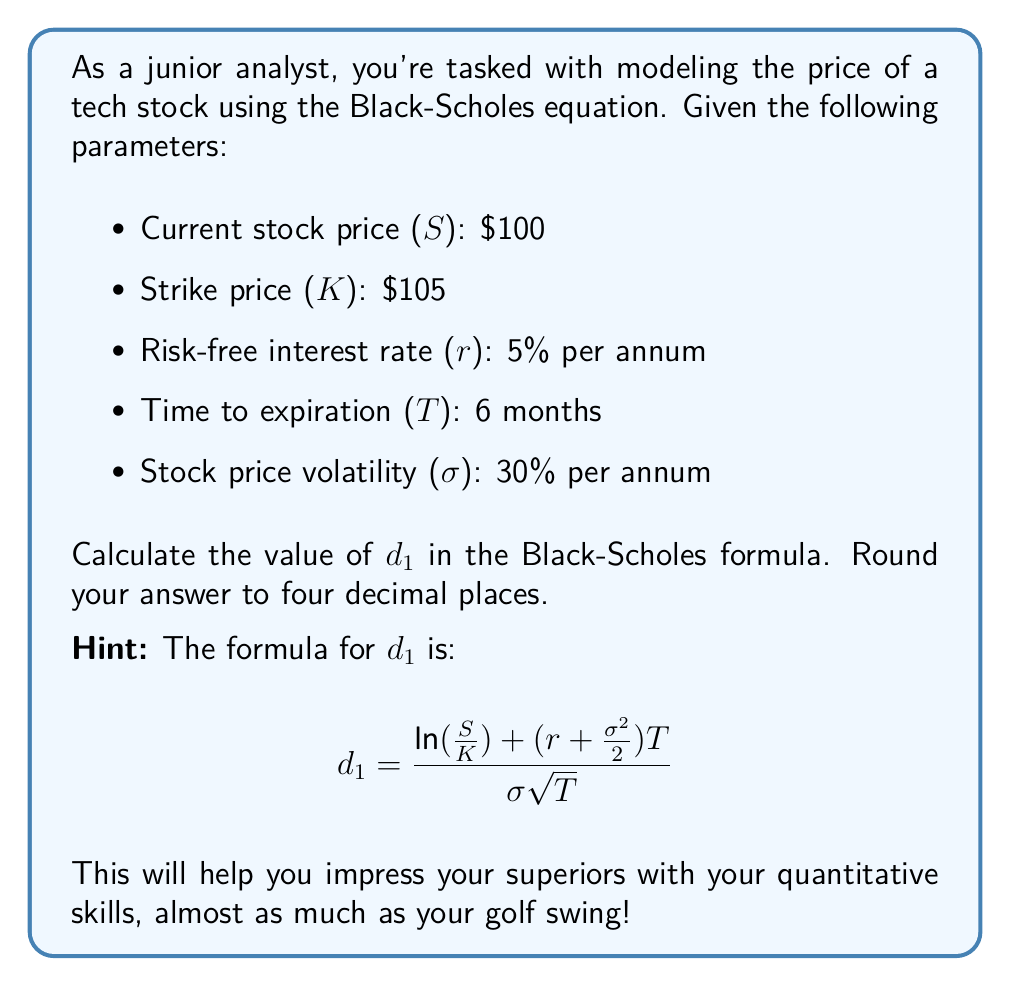Provide a solution to this math problem. Let's break this down step-by-step:

1) We have the following values:
   S = $100
   K = $105
   r = 5% = 0.05
   T = 6 months = 0.5 years
   σ = 30% = 0.3

2) Let's substitute these into the formula for d₁:

   $$d_1 = \frac{\ln(\frac{S}{K}) + (r + \frac{\sigma^2}{2})T}{\sigma\sqrt{T}}$$

3) First, let's calculate $\frac{S}{K}$:
   $\frac{S}{K} = \frac{100}{105} \approx 0.9524$

4) Now, let's calculate $\ln(\frac{S}{K})$:
   $\ln(0.9524) \approx -0.0488$

5) Next, let's calculate $(r + \frac{\sigma^2}{2})$:
   $0.05 + \frac{0.3^2}{2} = 0.05 + 0.045 = 0.095$

6) Multiply this by T:
   $0.095 * 0.5 = 0.0475$

7) Add this to $\ln(\frac{S}{K})$:
   $-0.0488 + 0.0475 = -0.0013$

8) Now for the denominator, calculate $\sigma\sqrt{T}$:
   $0.3 * \sqrt{0.5} \approx 0.2121$

9) Finally, divide:
   $\frac{-0.0013}{0.2121} \approx -0.0061$

10) Rounding to four decimal places:
    $-0.0061$ rounds to $-0.0061$
Answer: $-0.0061$ 